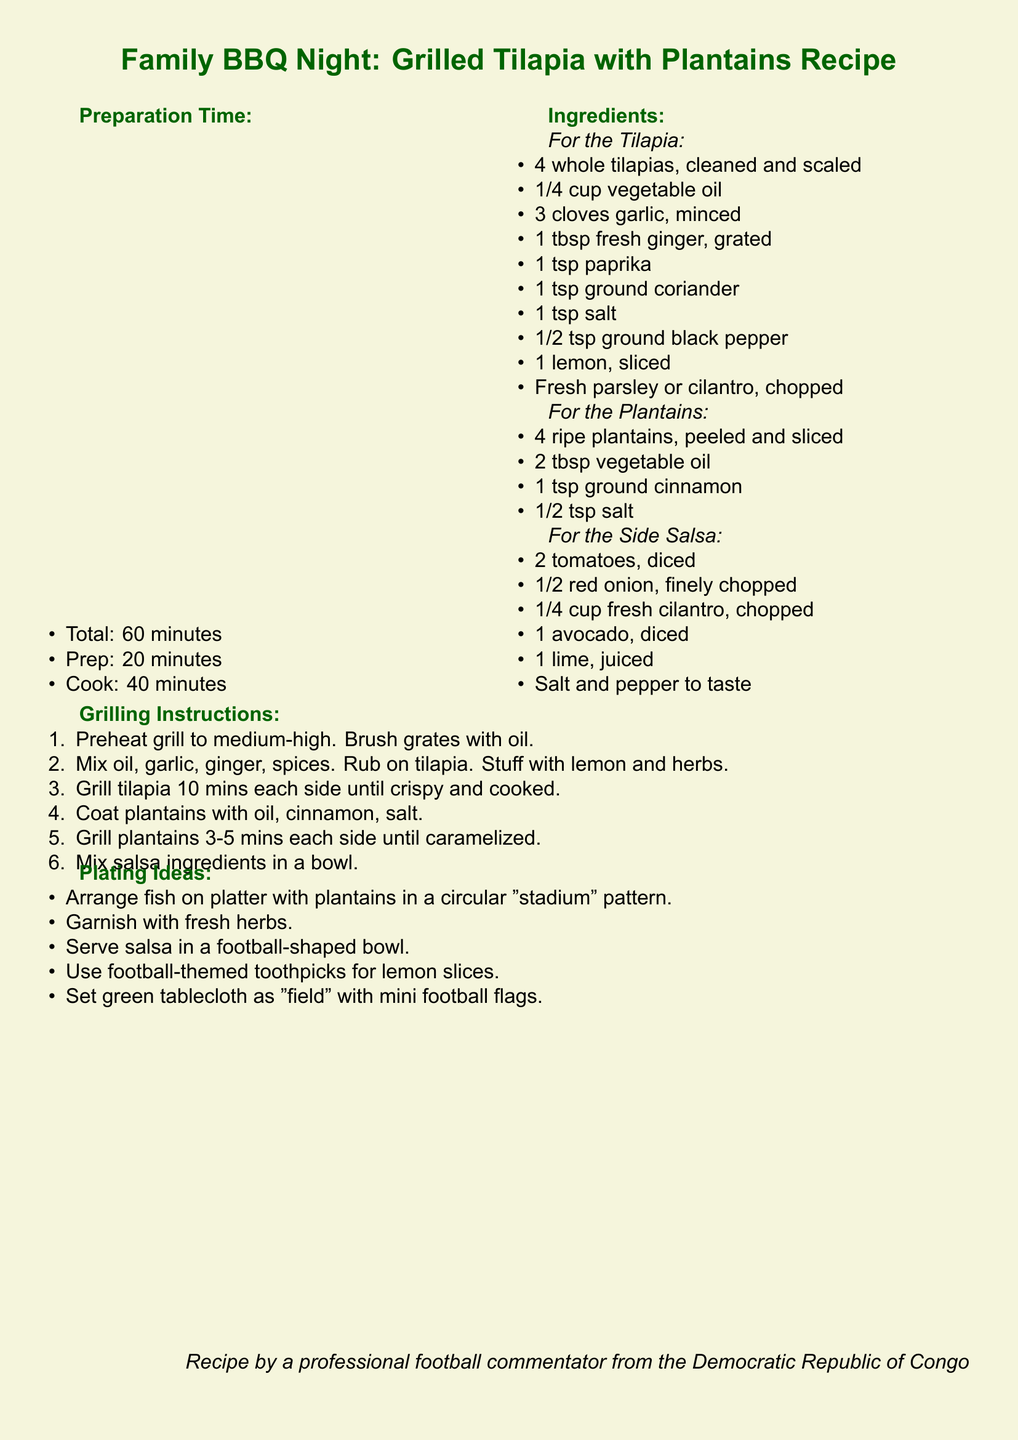What is the total preparation time? The total preparation time is specified in the document and it states that it takes 60 minutes.
Answer: 60 minutes How many cloves of garlic are needed? The document lists the ingredients for the tilapia and mentions that 3 cloves of garlic are needed.
Answer: 3 cloves What temperature should the grill be preheated to? The grilling instructions inform that the grill should be preheated to medium-high.
Answer: Medium-high How many ripe plantains are required? The ingredients list for the plantains indicates that 4 ripe plantains are needed.
Answer: 4 ripe plantains What is the main theme for the plating ideas? The plating ideas section suggests using a football theme for arranging and serving the dish.
Answer: Football theme What is the cooking time for the tilapia per side? The grilling instructions detail that the tilapia should be grilled for 10 minutes on each side.
Answer: 10 minutes What fresh herb is suggested to garnish the dish? The plating ideas mention garnishing with fresh herbs, specifically parsley or cilantro.
Answer: Fresh herbs What is the juicing fruit needed for the salsa? The ingredients for the salsa include 1 lime, which is mentioned as needing to be juiced.
Answer: 1 lime 